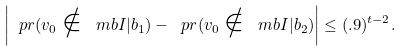<formula> <loc_0><loc_0><loc_500><loc_500>\left | \ p r ( v _ { 0 } \notin \ m b { I } | b _ { 1 } ) - \ p r ( v _ { 0 } \notin \ m b { I } | b _ { 2 } ) \right | \leq ( . 9 ) ^ { t - 2 } .</formula> 